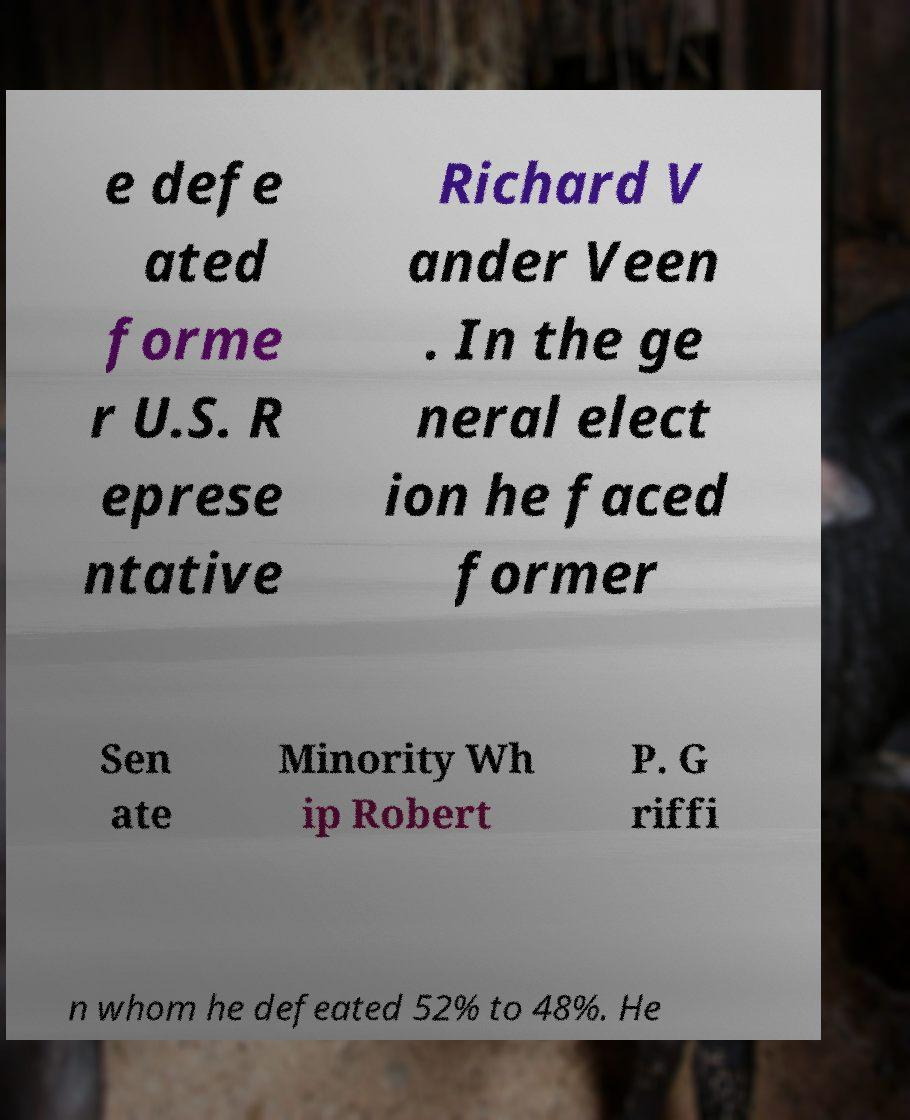For documentation purposes, I need the text within this image transcribed. Could you provide that? e defe ated forme r U.S. R eprese ntative Richard V ander Veen . In the ge neral elect ion he faced former Sen ate Minority Wh ip Robert P. G riffi n whom he defeated 52% to 48%. He 